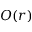<formula> <loc_0><loc_0><loc_500><loc_500>O ( r )</formula> 